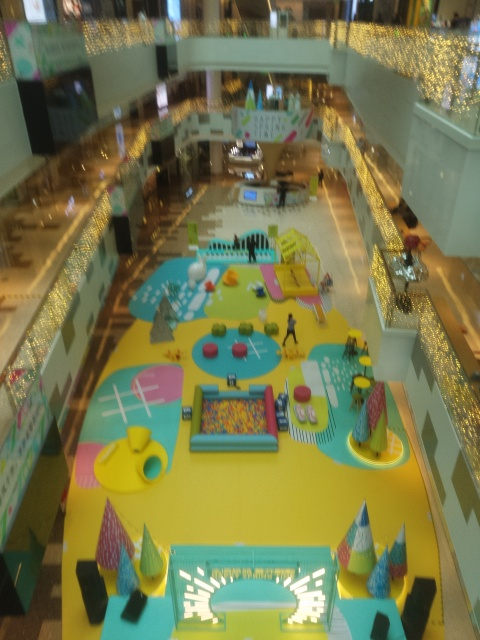Is the lighting sufficient in the image? The lighting in the image appears to provide adequate visibility, illuminating the central area and artistic installations effectively. However, the photo is taken from a high angle and is slightly out of focus, which might affect the perception of lighting quality. 